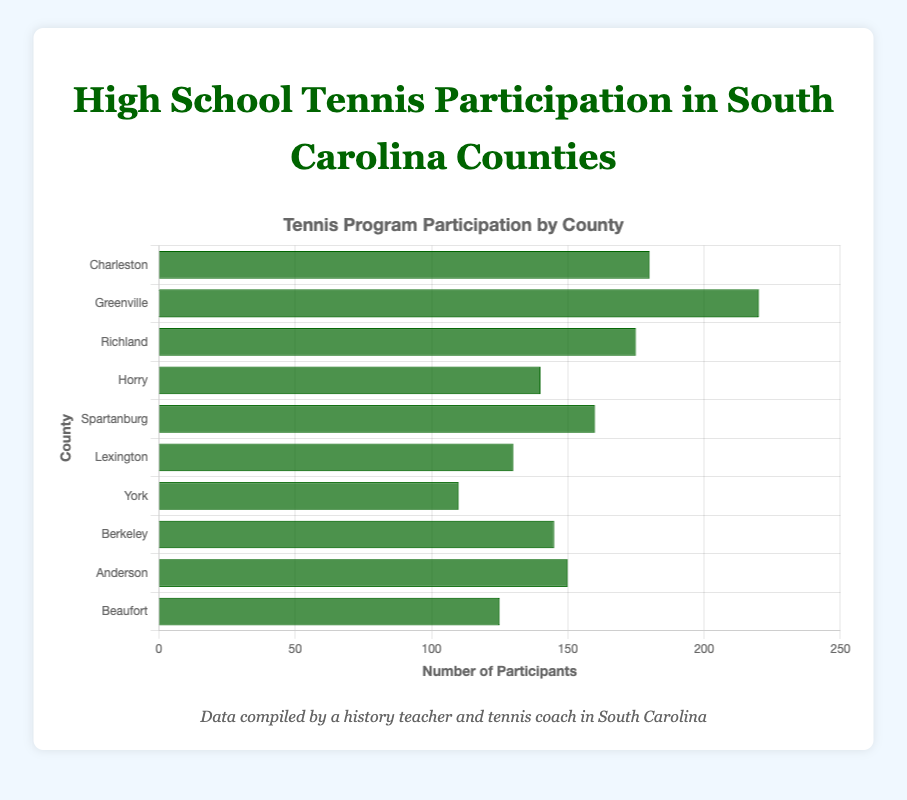Which county has the highest number of high school tennis participants? By visually inspecting the bar chart, the tallest bar represents the number of participants in each county. The tallest bar, thus the highest number, belongs to Greenville County.
Answer: Greenville Which two counties have the most similar number of participants? By comparing the lengths of the bars, Spartanburg (160) and Anderson (150) counties have the most similar number of participants, only differing by 10 participants.
Answer: Spartanburg and Anderson How many total participants are there in the top three counties with the highest participation rates? Identify the top three counties with the longest bars: Greenville (220), Charleston (180), and Richland (175). Add the participants: 220 + 180 + 175 = 575.
Answer: 575 What is the average number of participants across all counties? Add the participants for all counties: 220 (Greenville) + 180 (Charleston) + 175 (Richland) + 160 (Spartanburg) + 150 (Anderson) + 145 (Berkeley) + 140 (Horry) + 130 (Lexington) + 125 (Beaufort) + 110 (York) = 1535. Divide by the number of counties (10): 1535/10 = 153.5.
Answer: 153.5 Which county has fewer participants, Horry or Berkeley, and by how many? Compare the bars for Horry (140) and Berkeley (145). Berkeley has more participants than Horry. Calculate the difference: 145 - 140 = 5 participants.
Answer: Horry, by 5 participants What is the difference in participants between the county with the most and the county with the least participants? Identify the county with the most participants as Greenville (220) and the county with the least participants as York (110). Calculate the difference: 220 - 110 = 110 participants.
Answer: 110 Which counties have more than 150 participants? Identify the bars extending beyond the 150 mark: Greenville (220), Charleston (180), Richland (175), and Spartanburg (160).
Answer: Greenville, Charleston, Richland, Spartanburg Are there more counties with participants below or above the number in Anderson County? Compare Anderson's number (150) with all others: Below Anderson (Berkeley, Horry, Lexington, Beaufort, York = 5 counties), Above Anderson (Greenville, Charleston, Richland, Spartanburg = 4 counties).
Answer: Below What is the median number of participants across all counties? List the participants in ascending order: 110, 125, 130, 140, 145, 150, 160, 175, 180, 220. The median is the average of the 5th and 6th values: (145 + 150) / 2 = 147.5.
Answer: 147.5 